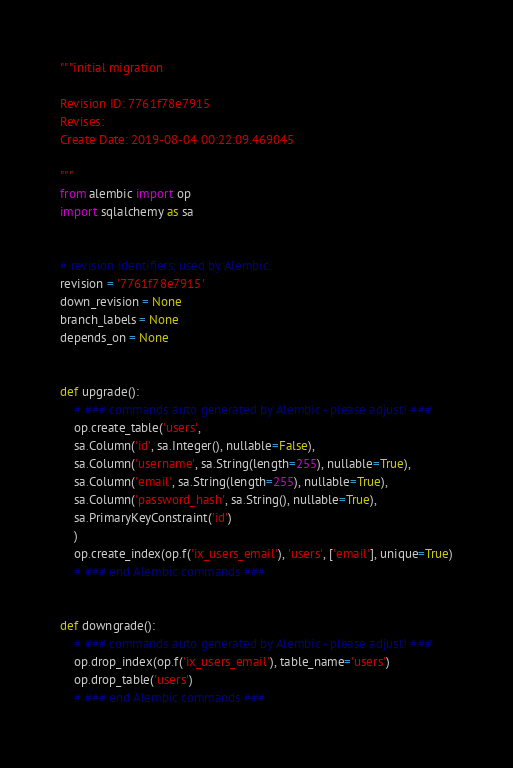Convert code to text. <code><loc_0><loc_0><loc_500><loc_500><_Python_>"""initial migration

Revision ID: 7761f78e7915
Revises: 
Create Date: 2019-08-04 00:22:09.469045

"""
from alembic import op
import sqlalchemy as sa


# revision identifiers, used by Alembic.
revision = '7761f78e7915'
down_revision = None
branch_labels = None
depends_on = None


def upgrade():
    # ### commands auto generated by Alembic - please adjust! ###
    op.create_table('users',
    sa.Column('id', sa.Integer(), nullable=False),
    sa.Column('username', sa.String(length=255), nullable=True),
    sa.Column('email', sa.String(length=255), nullable=True),
    sa.Column('password_hash', sa.String(), nullable=True),
    sa.PrimaryKeyConstraint('id')
    )
    op.create_index(op.f('ix_users_email'), 'users', ['email'], unique=True)
    # ### end Alembic commands ###


def downgrade():
    # ### commands auto generated by Alembic - please adjust! ###
    op.drop_index(op.f('ix_users_email'), table_name='users')
    op.drop_table('users')
    # ### end Alembic commands ###
</code> 